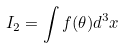Convert formula to latex. <formula><loc_0><loc_0><loc_500><loc_500>I _ { 2 } = \int f ( \theta ) d ^ { 3 } x</formula> 